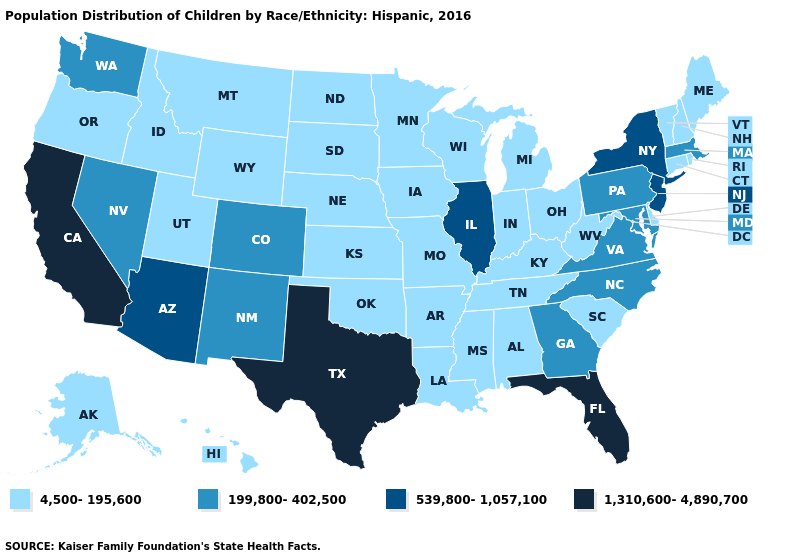Does Tennessee have the lowest value in the USA?
Answer briefly. Yes. Among the states that border Virginia , does West Virginia have the highest value?
Give a very brief answer. No. What is the lowest value in the South?
Give a very brief answer. 4,500-195,600. Does the map have missing data?
Concise answer only. No. Name the states that have a value in the range 1,310,600-4,890,700?
Short answer required. California, Florida, Texas. What is the value of Delaware?
Short answer required. 4,500-195,600. Among the states that border Colorado , does Arizona have the highest value?
Quick response, please. Yes. Does the first symbol in the legend represent the smallest category?
Concise answer only. Yes. What is the value of Colorado?
Short answer required. 199,800-402,500. Does California have the highest value in the West?
Keep it brief. Yes. What is the value of Texas?
Answer briefly. 1,310,600-4,890,700. How many symbols are there in the legend?
Quick response, please. 4. Name the states that have a value in the range 4,500-195,600?
Answer briefly. Alabama, Alaska, Arkansas, Connecticut, Delaware, Hawaii, Idaho, Indiana, Iowa, Kansas, Kentucky, Louisiana, Maine, Michigan, Minnesota, Mississippi, Missouri, Montana, Nebraska, New Hampshire, North Dakota, Ohio, Oklahoma, Oregon, Rhode Island, South Carolina, South Dakota, Tennessee, Utah, Vermont, West Virginia, Wisconsin, Wyoming. Name the states that have a value in the range 1,310,600-4,890,700?
Answer briefly. California, Florida, Texas. Does Florida have the highest value in the USA?
Answer briefly. Yes. 